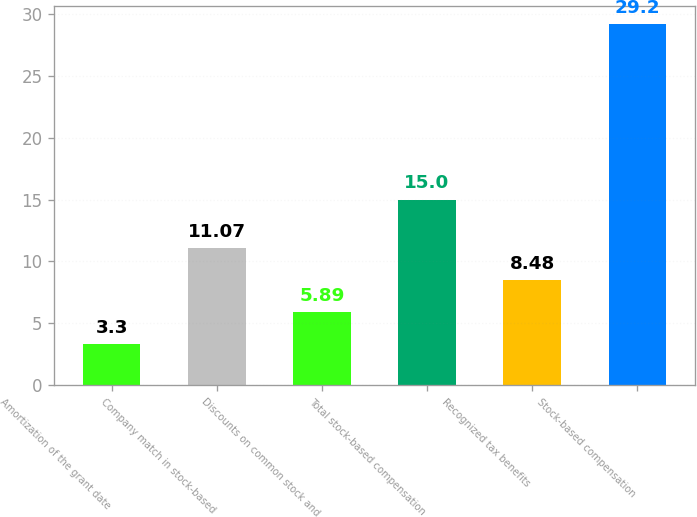<chart> <loc_0><loc_0><loc_500><loc_500><bar_chart><fcel>Amortization of the grant date<fcel>Company match in stock-based<fcel>Discounts on common stock and<fcel>Total stock-based compensation<fcel>Recognized tax benefits<fcel>Stock-based compensation<nl><fcel>3.3<fcel>11.07<fcel>5.89<fcel>15<fcel>8.48<fcel>29.2<nl></chart> 